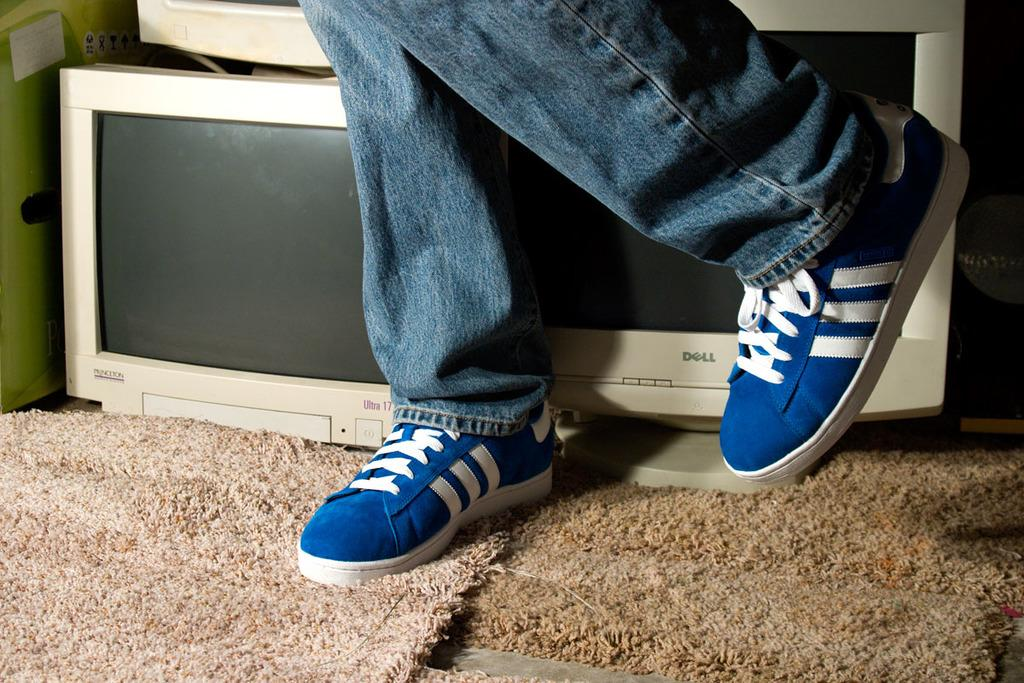What is visible in the image related to a person? There are a person's legs with shoes in the image. What objects are placed on a cloth in the image? There are systems placed on a cloth in the image. What type of garden can be seen in the image? There is no garden present in the image. What month is depicted in the image? The image does not show a specific month or time of year. 